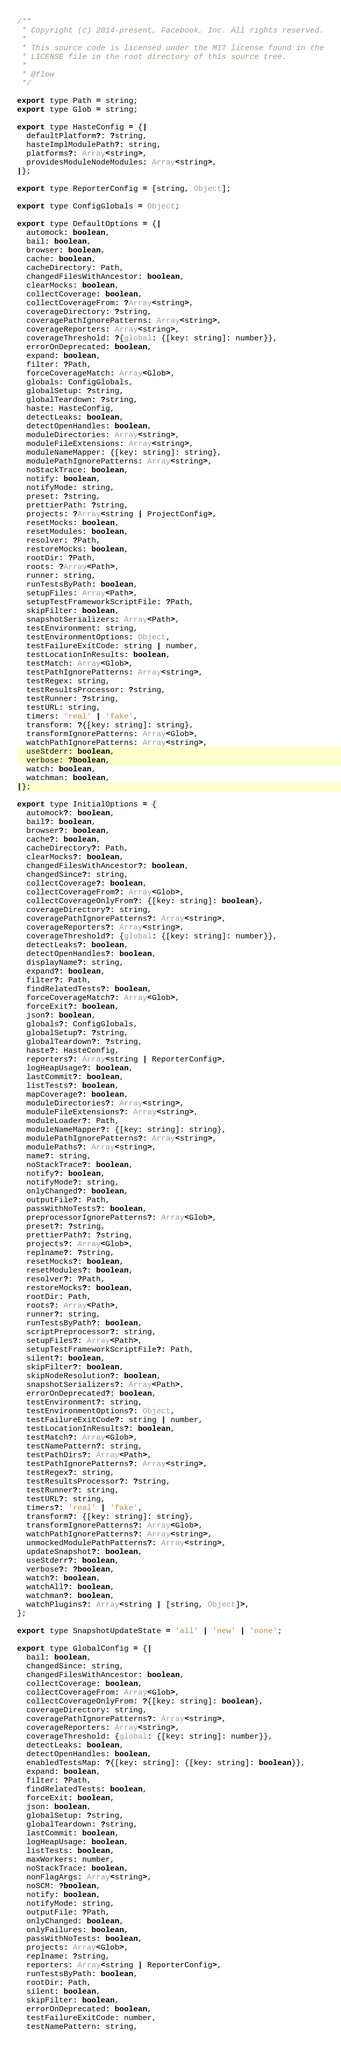Convert code to text. <code><loc_0><loc_0><loc_500><loc_500><_JavaScript_>/**
 * Copyright (c) 2014-present, Facebook, Inc. All rights reserved.
 *
 * This source code is licensed under the MIT license found in the
 * LICENSE file in the root directory of this source tree.
 *
 * @flow
 */

export type Path = string;
export type Glob = string;

export type HasteConfig = {|
  defaultPlatform?: ?string,
  hasteImplModulePath?: string,
  platforms?: Array<string>,
  providesModuleNodeModules: Array<string>,
|};

export type ReporterConfig = [string, Object];

export type ConfigGlobals = Object;

export type DefaultOptions = {|
  automock: boolean,
  bail: boolean,
  browser: boolean,
  cache: boolean,
  cacheDirectory: Path,
  changedFilesWithAncestor: boolean,
  clearMocks: boolean,
  collectCoverage: boolean,
  collectCoverageFrom: ?Array<string>,
  coverageDirectory: ?string,
  coveragePathIgnorePatterns: Array<string>,
  coverageReporters: Array<string>,
  coverageThreshold: ?{global: {[key: string]: number}},
  errorOnDeprecated: boolean,
  expand: boolean,
  filter: ?Path,
  forceCoverageMatch: Array<Glob>,
  globals: ConfigGlobals,
  globalSetup: ?string,
  globalTeardown: ?string,
  haste: HasteConfig,
  detectLeaks: boolean,
  detectOpenHandles: boolean,
  moduleDirectories: Array<string>,
  moduleFileExtensions: Array<string>,
  moduleNameMapper: {[key: string]: string},
  modulePathIgnorePatterns: Array<string>,
  noStackTrace: boolean,
  notify: boolean,
  notifyMode: string,
  preset: ?string,
  prettierPath: ?string,
  projects: ?Array<string | ProjectConfig>,
  resetMocks: boolean,
  resetModules: boolean,
  resolver: ?Path,
  restoreMocks: boolean,
  rootDir: ?Path,
  roots: ?Array<Path>,
  runner: string,
  runTestsByPath: boolean,
  setupFiles: Array<Path>,
  setupTestFrameworkScriptFile: ?Path,
  skipFilter: boolean,
  snapshotSerializers: Array<Path>,
  testEnvironment: string,
  testEnvironmentOptions: Object,
  testFailureExitCode: string | number,
  testLocationInResults: boolean,
  testMatch: Array<Glob>,
  testPathIgnorePatterns: Array<string>,
  testRegex: string,
  testResultsProcessor: ?string,
  testRunner: ?string,
  testURL: string,
  timers: 'real' | 'fake',
  transform: ?{[key: string]: string},
  transformIgnorePatterns: Array<Glob>,
  watchPathIgnorePatterns: Array<string>,
  useStderr: boolean,
  verbose: ?boolean,
  watch: boolean,
  watchman: boolean,
|};

export type InitialOptions = {
  automock?: boolean,
  bail?: boolean,
  browser?: boolean,
  cache?: boolean,
  cacheDirectory?: Path,
  clearMocks?: boolean,
  changedFilesWithAncestor?: boolean,
  changedSince?: string,
  collectCoverage?: boolean,
  collectCoverageFrom?: Array<Glob>,
  collectCoverageOnlyFrom?: {[key: string]: boolean},
  coverageDirectory?: string,
  coveragePathIgnorePatterns?: Array<string>,
  coverageReporters?: Array<string>,
  coverageThreshold?: {global: {[key: string]: number}},
  detectLeaks?: boolean,
  detectOpenHandles?: boolean,
  displayName?: string,
  expand?: boolean,
  filter?: Path,
  findRelatedTests?: boolean,
  forceCoverageMatch?: Array<Glob>,
  forceExit?: boolean,
  json?: boolean,
  globals?: ConfigGlobals,
  globalSetup?: ?string,
  globalTeardown?: ?string,
  haste?: HasteConfig,
  reporters?: Array<string | ReporterConfig>,
  logHeapUsage?: boolean,
  lastCommit?: boolean,
  listTests?: boolean,
  mapCoverage?: boolean,
  moduleDirectories?: Array<string>,
  moduleFileExtensions?: Array<string>,
  moduleLoader?: Path,
  moduleNameMapper?: {[key: string]: string},
  modulePathIgnorePatterns?: Array<string>,
  modulePaths?: Array<string>,
  name?: string,
  noStackTrace?: boolean,
  notify?: boolean,
  notifyMode?: string,
  onlyChanged?: boolean,
  outputFile?: Path,
  passWithNoTests?: boolean,
  preprocessorIgnorePatterns?: Array<Glob>,
  preset?: ?string,
  prettierPath?: ?string,
  projects?: Array<Glob>,
  replname?: ?string,
  resetMocks?: boolean,
  resetModules?: boolean,
  resolver?: ?Path,
  restoreMocks?: boolean,
  rootDir: Path,
  roots?: Array<Path>,
  runner?: string,
  runTestsByPath?: boolean,
  scriptPreprocessor?: string,
  setupFiles?: Array<Path>,
  setupTestFrameworkScriptFile?: Path,
  silent?: boolean,
  skipFilter?: boolean,
  skipNodeResolution?: boolean,
  snapshotSerializers?: Array<Path>,
  errorOnDeprecated?: boolean,
  testEnvironment?: string,
  testEnvironmentOptions?: Object,
  testFailureExitCode?: string | number,
  testLocationInResults?: boolean,
  testMatch?: Array<Glob>,
  testNamePattern?: string,
  testPathDirs?: Array<Path>,
  testPathIgnorePatterns?: Array<string>,
  testRegex?: string,
  testResultsProcessor?: ?string,
  testRunner?: string,
  testURL?: string,
  timers?: 'real' | 'fake',
  transform?: {[key: string]: string},
  transformIgnorePatterns?: Array<Glob>,
  watchPathIgnorePatterns?: Array<string>,
  unmockedModulePathPatterns?: Array<string>,
  updateSnapshot?: boolean,
  useStderr?: boolean,
  verbose?: ?boolean,
  watch?: boolean,
  watchAll?: boolean,
  watchman?: boolean,
  watchPlugins?: Array<string | [string, Object]>,
};

export type SnapshotUpdateState = 'all' | 'new' | 'none';

export type GlobalConfig = {|
  bail: boolean,
  changedSince: string,
  changedFilesWithAncestor: boolean,
  collectCoverage: boolean,
  collectCoverageFrom: Array<Glob>,
  collectCoverageOnlyFrom: ?{[key: string]: boolean},
  coverageDirectory: string,
  coveragePathIgnorePatterns?: Array<string>,
  coverageReporters: Array<string>,
  coverageThreshold: {global: {[key: string]: number}},
  detectLeaks: boolean,
  detectOpenHandles: boolean,
  enabledTestsMap: ?{[key: string]: {[key: string]: boolean}},
  expand: boolean,
  filter: ?Path,
  findRelatedTests: boolean,
  forceExit: boolean,
  json: boolean,
  globalSetup: ?string,
  globalTeardown: ?string,
  lastCommit: boolean,
  logHeapUsage: boolean,
  listTests: boolean,
  maxWorkers: number,
  noStackTrace: boolean,
  nonFlagArgs: Array<string>,
  noSCM: ?boolean,
  notify: boolean,
  notifyMode: string,
  outputFile: ?Path,
  onlyChanged: boolean,
  onlyFailures: boolean,
  passWithNoTests: boolean,
  projects: Array<Glob>,
  replname: ?string,
  reporters: Array<string | ReporterConfig>,
  runTestsByPath: boolean,
  rootDir: Path,
  silent: boolean,
  skipFilter: boolean,
  errorOnDeprecated: boolean,
  testFailureExitCode: number,
  testNamePattern: string,</code> 